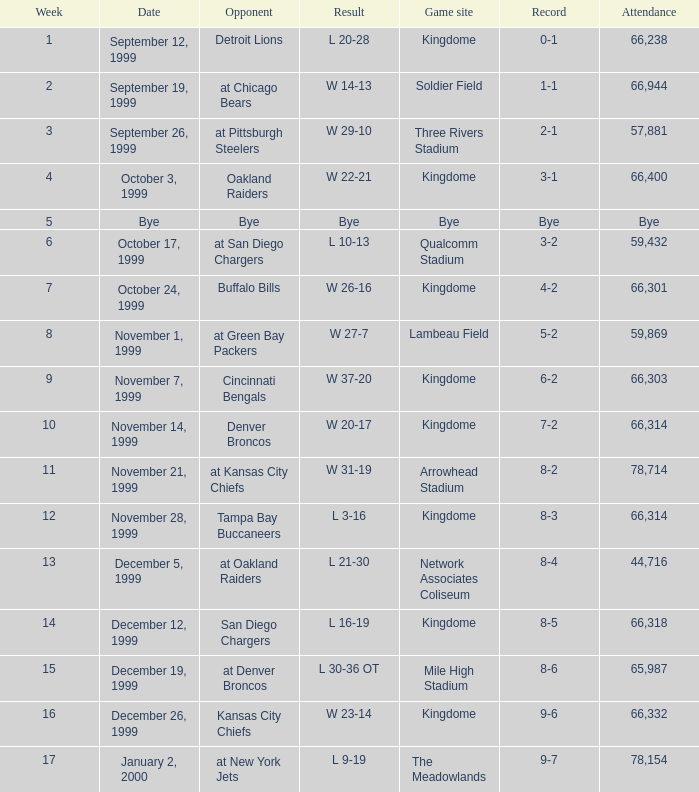For the game that was played on week 2, what is the record? 1-1. 